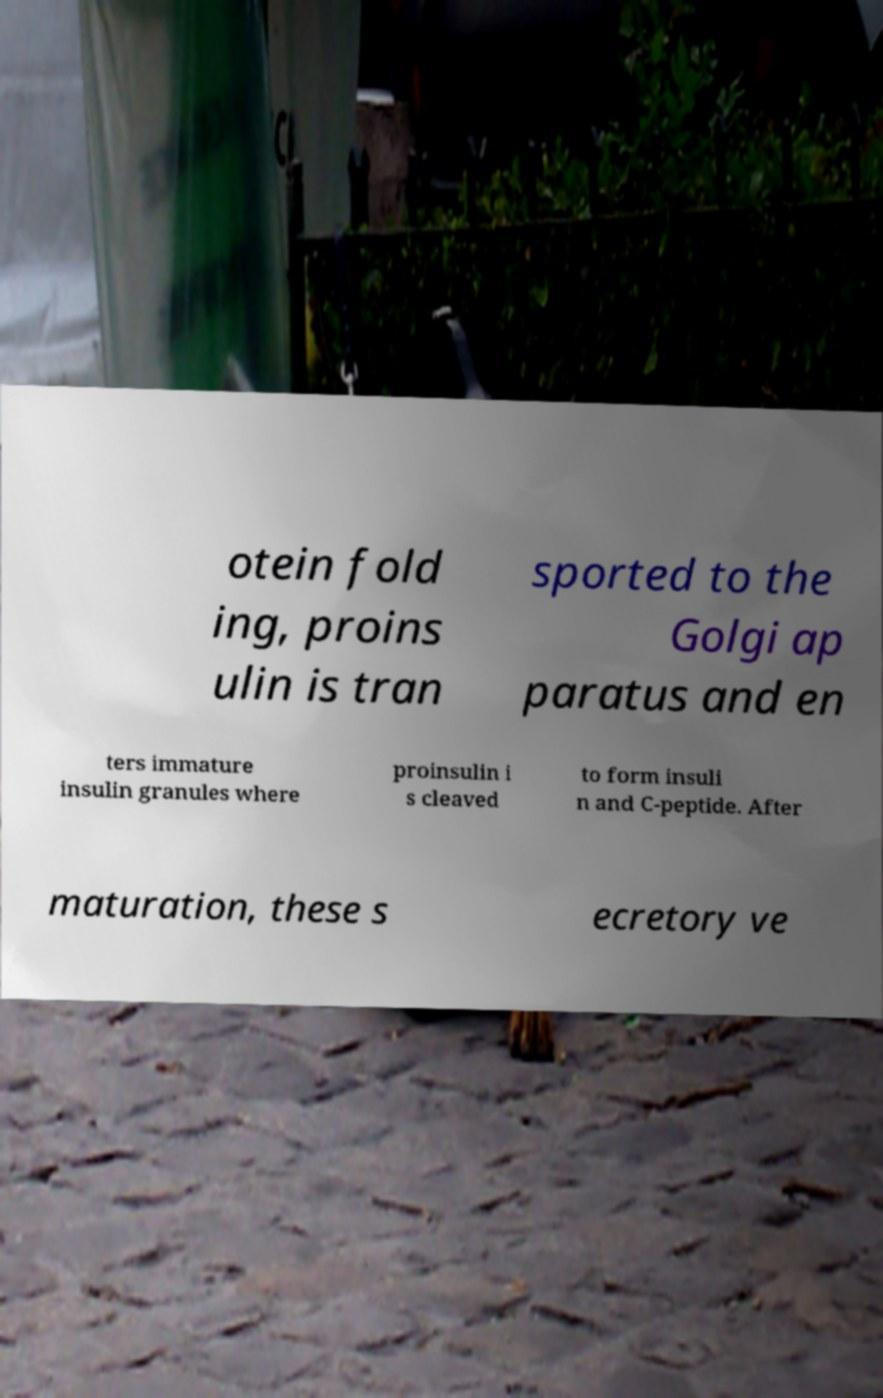What messages or text are displayed in this image? I need them in a readable, typed format. otein fold ing, proins ulin is tran sported to the Golgi ap paratus and en ters immature insulin granules where proinsulin i s cleaved to form insuli n and C-peptide. After maturation, these s ecretory ve 